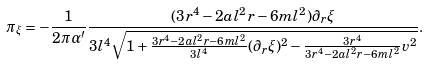Convert formula to latex. <formula><loc_0><loc_0><loc_500><loc_500>\pi _ { \xi } = - { \frac { 1 } { 2 \pi \alpha ^ { \prime } } } \frac { ( 3 r ^ { 4 } - 2 a l ^ { 2 } r - 6 m l ^ { 2 } ) \partial _ { r } \xi } { { 3 l ^ { 4 } \sqrt { 1 + \frac { 3 r ^ { 4 } - 2 a l ^ { 2 } r - 6 m l ^ { 2 } } { 3 l ^ { 4 } } ( \partial _ { r } \xi ) ^ { 2 } - \frac { 3 r ^ { 4 } } { 3 r ^ { 4 } - 2 a l ^ { 2 } r - 6 m l ^ { 2 } } v ^ { 2 } } } } .</formula> 